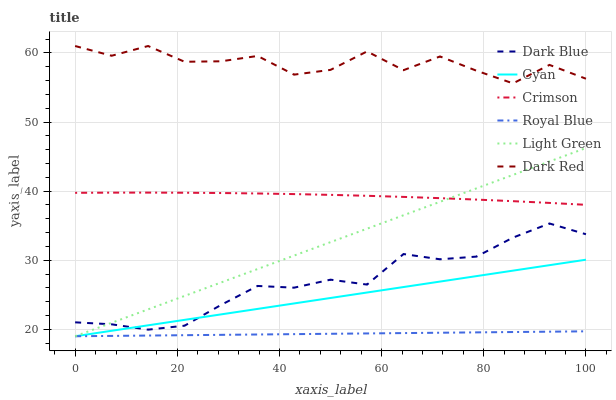Does Royal Blue have the minimum area under the curve?
Answer yes or no. Yes. Does Dark Red have the maximum area under the curve?
Answer yes or no. Yes. Does Dark Blue have the minimum area under the curve?
Answer yes or no. No. Does Dark Blue have the maximum area under the curve?
Answer yes or no. No. Is Cyan the smoothest?
Answer yes or no. Yes. Is Dark Red the roughest?
Answer yes or no. Yes. Is Dark Blue the smoothest?
Answer yes or no. No. Is Dark Blue the roughest?
Answer yes or no. No. Does Dark Blue have the lowest value?
Answer yes or no. No. Does Dark Blue have the highest value?
Answer yes or no. No. Is Cyan less than Crimson?
Answer yes or no. Yes. Is Dark Red greater than Crimson?
Answer yes or no. Yes. Does Cyan intersect Crimson?
Answer yes or no. No. 